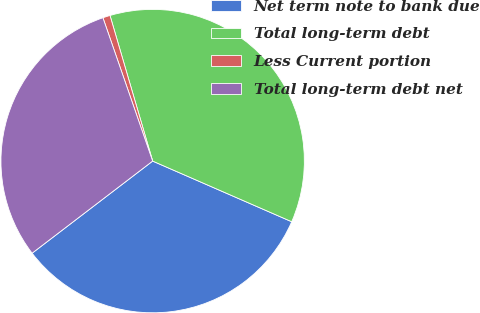<chart> <loc_0><loc_0><loc_500><loc_500><pie_chart><fcel>Net term note to bank due<fcel>Total long-term debt<fcel>Less Current portion<fcel>Total long-term debt net<nl><fcel>33.07%<fcel>36.08%<fcel>0.78%<fcel>30.07%<nl></chart> 